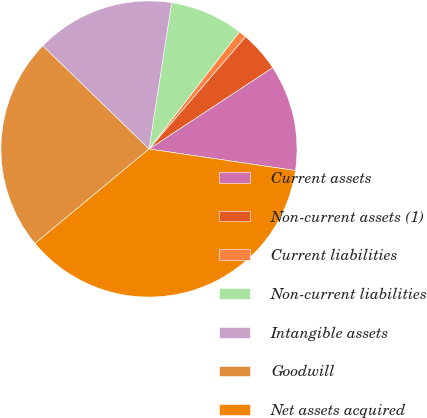Convert chart to OTSL. <chart><loc_0><loc_0><loc_500><loc_500><pie_chart><fcel>Current assets<fcel>Non-current assets (1)<fcel>Current liabilities<fcel>Non-current liabilities<fcel>Intangible assets<fcel>Goodwill<fcel>Net assets acquired<nl><fcel>11.59%<fcel>4.43%<fcel>0.85%<fcel>8.01%<fcel>15.18%<fcel>23.28%<fcel>36.67%<nl></chart> 